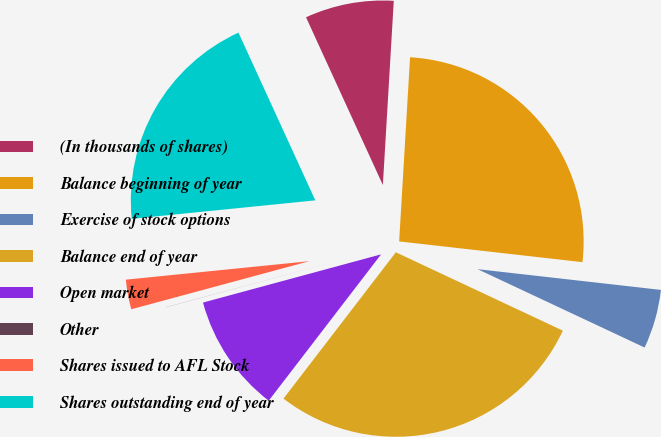<chart> <loc_0><loc_0><loc_500><loc_500><pie_chart><fcel>(In thousands of shares)<fcel>Balance beginning of year<fcel>Exercise of stock options<fcel>Balance end of year<fcel>Open market<fcel>Other<fcel>Shares issued to AFL Stock<fcel>Shares outstanding end of year<nl><fcel>7.78%<fcel>25.85%<fcel>5.19%<fcel>28.44%<fcel>10.37%<fcel>0.01%<fcel>2.6%<fcel>19.76%<nl></chart> 